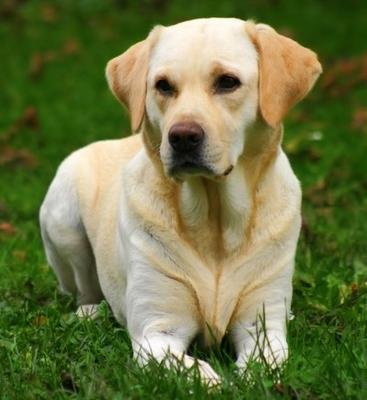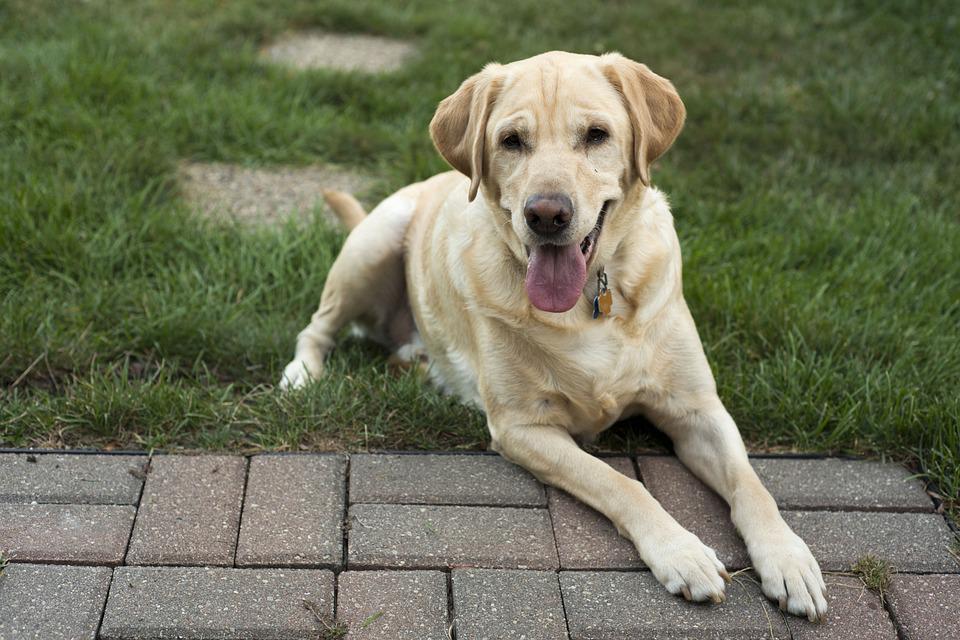The first image is the image on the left, the second image is the image on the right. Examine the images to the left and right. Is the description "A ball sits on the grass in front of one of the dogs." accurate? Answer yes or no. No. The first image is the image on the left, the second image is the image on the right. Given the left and right images, does the statement "An image shows one dog in the grass with a ball." hold true? Answer yes or no. No. 